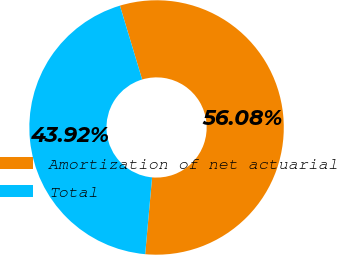Convert chart. <chart><loc_0><loc_0><loc_500><loc_500><pie_chart><fcel>Amortization of net actuarial<fcel>Total<nl><fcel>56.08%<fcel>43.92%<nl></chart> 